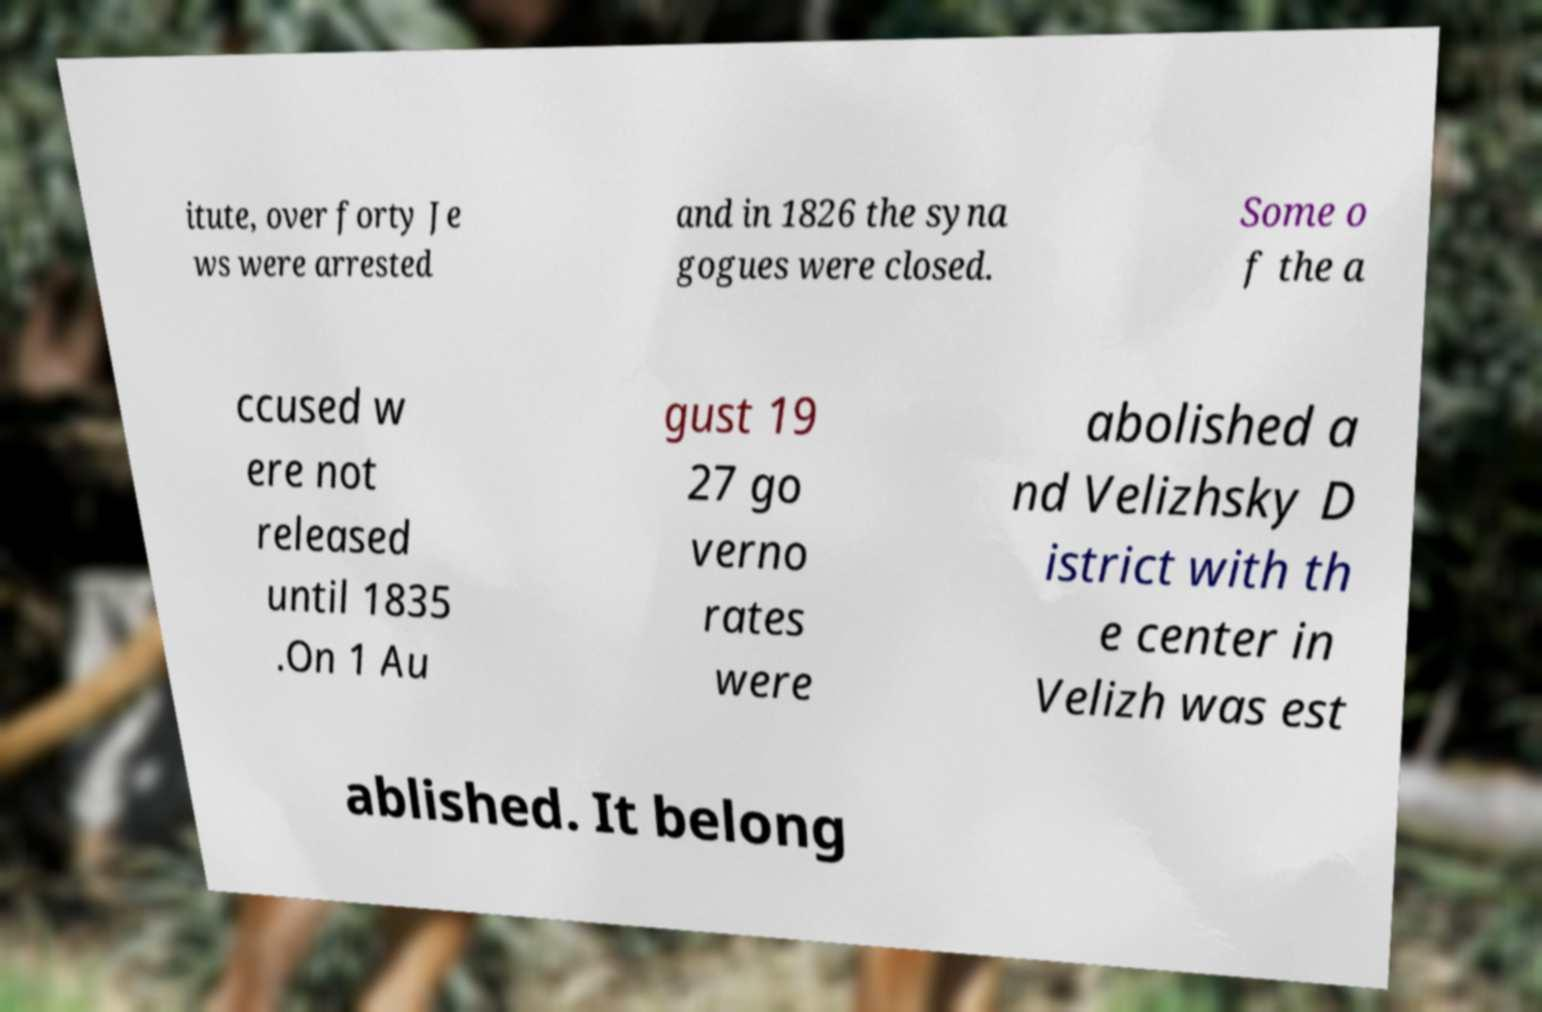Could you extract and type out the text from this image? itute, over forty Je ws were arrested and in 1826 the syna gogues were closed. Some o f the a ccused w ere not released until 1835 .On 1 Au gust 19 27 go verno rates were abolished a nd Velizhsky D istrict with th e center in Velizh was est ablished. It belong 